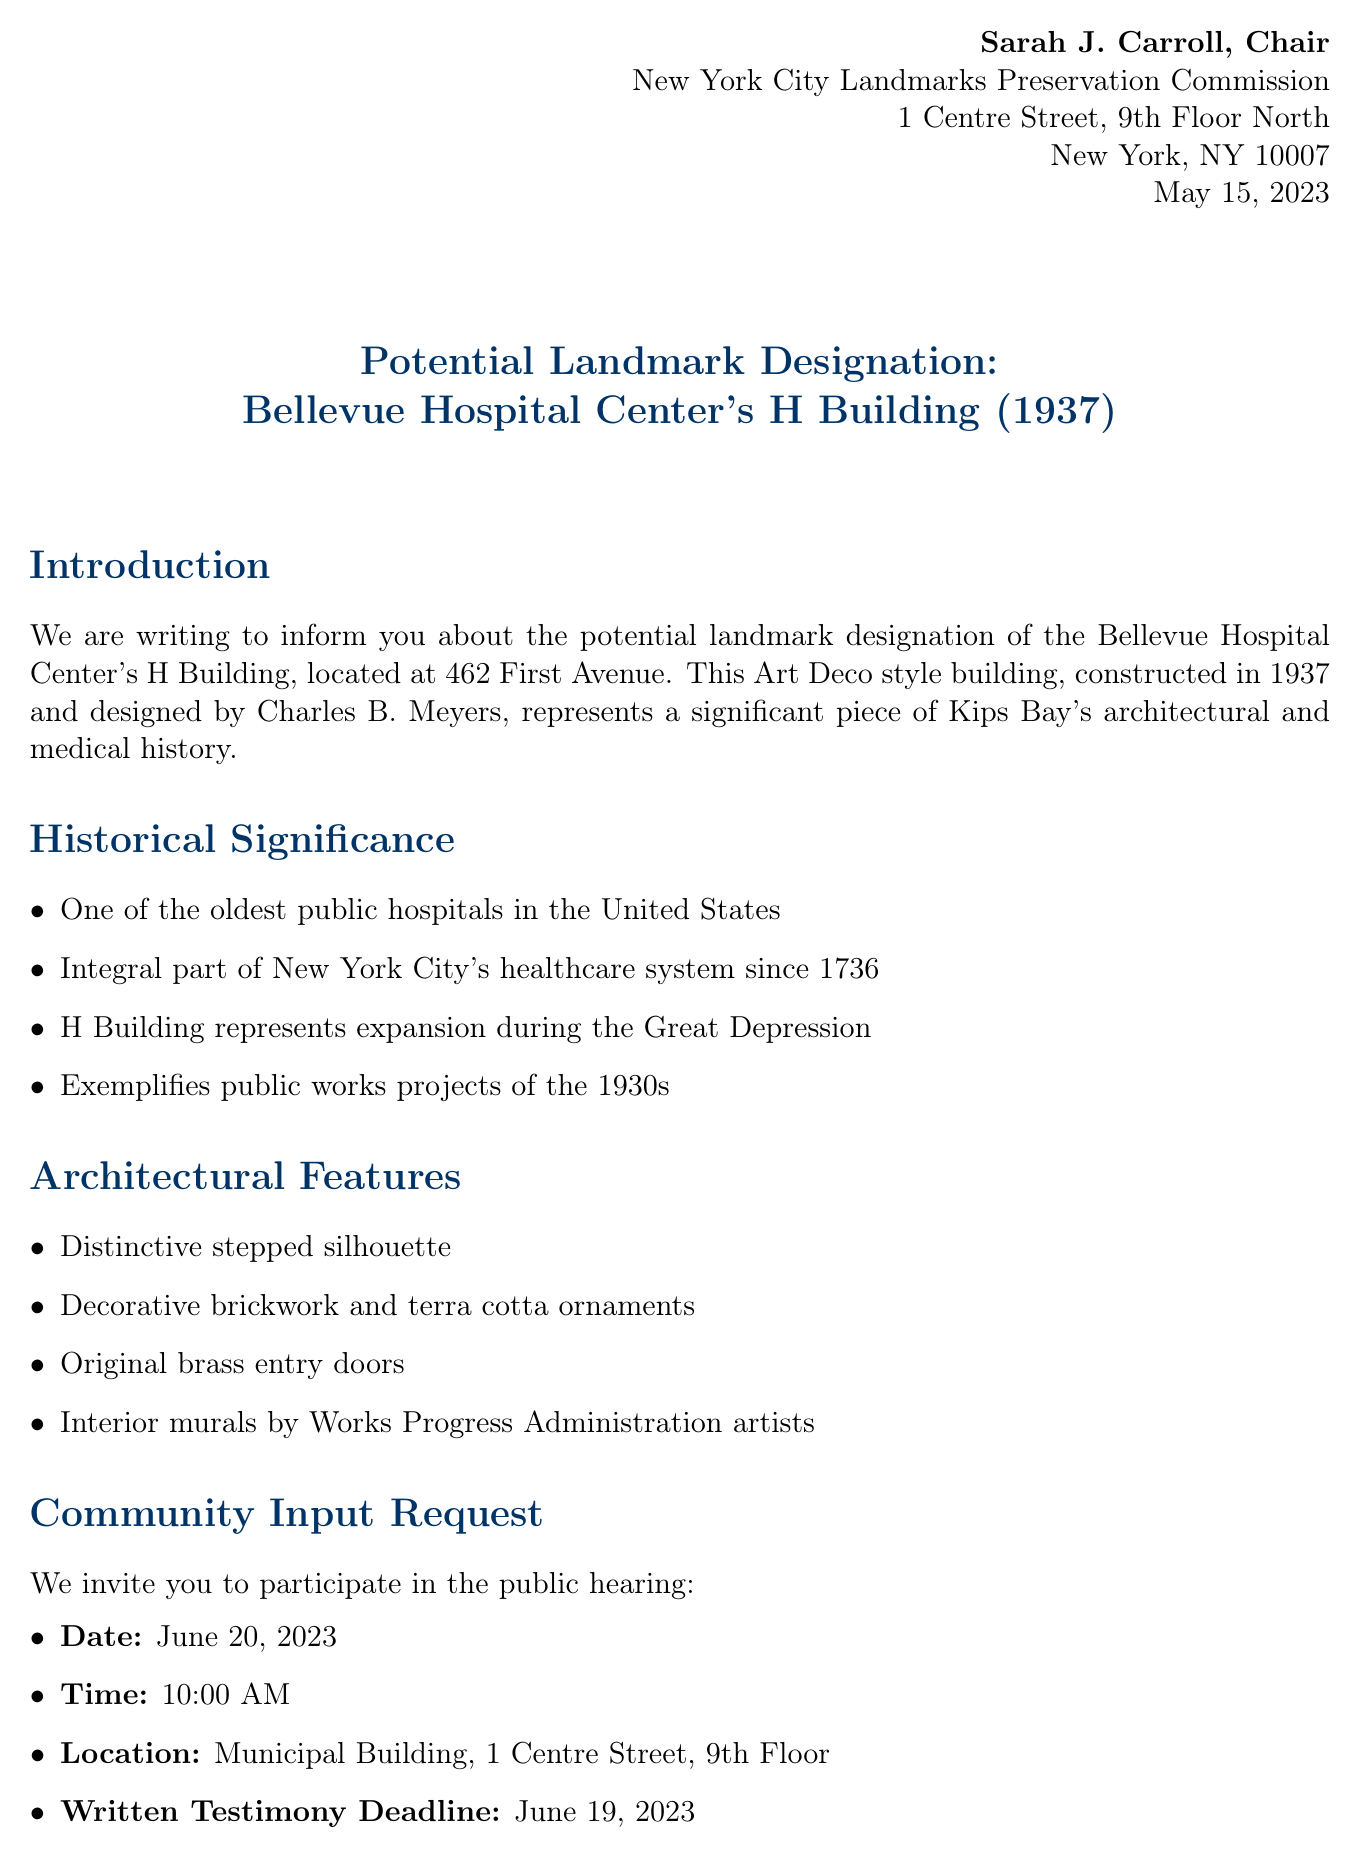What is the address of the H Building? The address can be found in the Introduction section, which states the location of the H Building.
Answer: 462 First Avenue Who designed the H Building? The architect's name is provided in the Introduction section as part of the background information.
Answer: Charles B. Meyers What year was the H Building constructed? The year of construction is mentioned in the Introduction section.
Answer: 1937 What is the date of the public hearing? This date is referenced in the Community Input Request section of the letter.
Answer: June 20, 2023 Which community board is associated with this designation? The local context section mentions the community board relevant to the H Building.
Answer: Manhattan Community Board 6 What architectural style characterizes the H Building? The document provides this information in the Introduction section.
Answer: Art Deco What incentive is mentioned related to landmark designation? Preservation benefits are listed in the document; one of them highlights a particular advantage of this designation.
Answer: Protection against demolition or unsympathetic alterations What can community organizers do regarding the designation? The role of community organizers is detailed in the document and lists their responsibilities.
Answer: Facilitate community discussions on the potential designation Who is the contact person for inquiries? The Contact Information section includes the name of the person handling inquiries.
Answer: Mark Silberman 